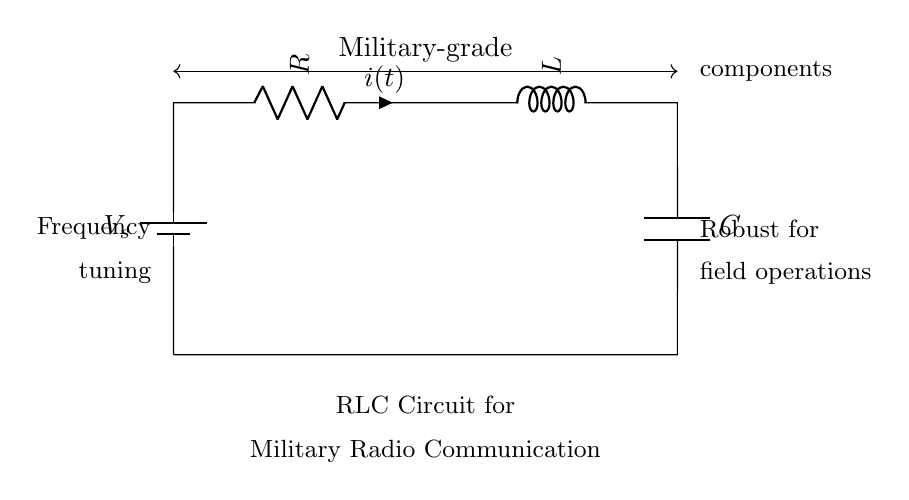What are the components in this circuit? The circuit consists of a resistor, an inductor, and a capacitor. These are the primary components visible in the schematic representation of the RLC circuit.
Answer: Resistor, Inductor, Capacitor What does the battery represent in this circuit? The battery provides a voltage source, which is necessary to power the RLC circuit. It establishes an electric potential difference that drives the current through the circuit.
Answer: Voltage source What is the function of the inductor in this RLC circuit? The inductor is used for energy storage in the magnetic field when current passes through it. It helps in tuning the frequency of the circuit, providing reactance that is frequency-dependent.
Answer: Energy storage How does the capacitor affect the circuit? The capacitor stores energy in the electric field and can alter the circuit's frequency response. It releases this energy back into the circuit, influencing the overall behavior of the RLC circuit under AC conditions.
Answer: Stores energy What is the significance of military-grade components in this circuit? Military-grade components are designed to withstand harsh conditions and ensure reliability in field operations, which is crucial for military radio communication equipment to maintain performance under extreme environments.
Answer: Reliability What does frequency tuning mean in the context of this RLC circuit? Frequency tuning refers to adjusting the values of the resistor, inductor, and capacitor to set the circuit to resonate at a specific frequency, optimizing the circuit for efficient communication in military applications.
Answer: Adjusting resonance frequency 